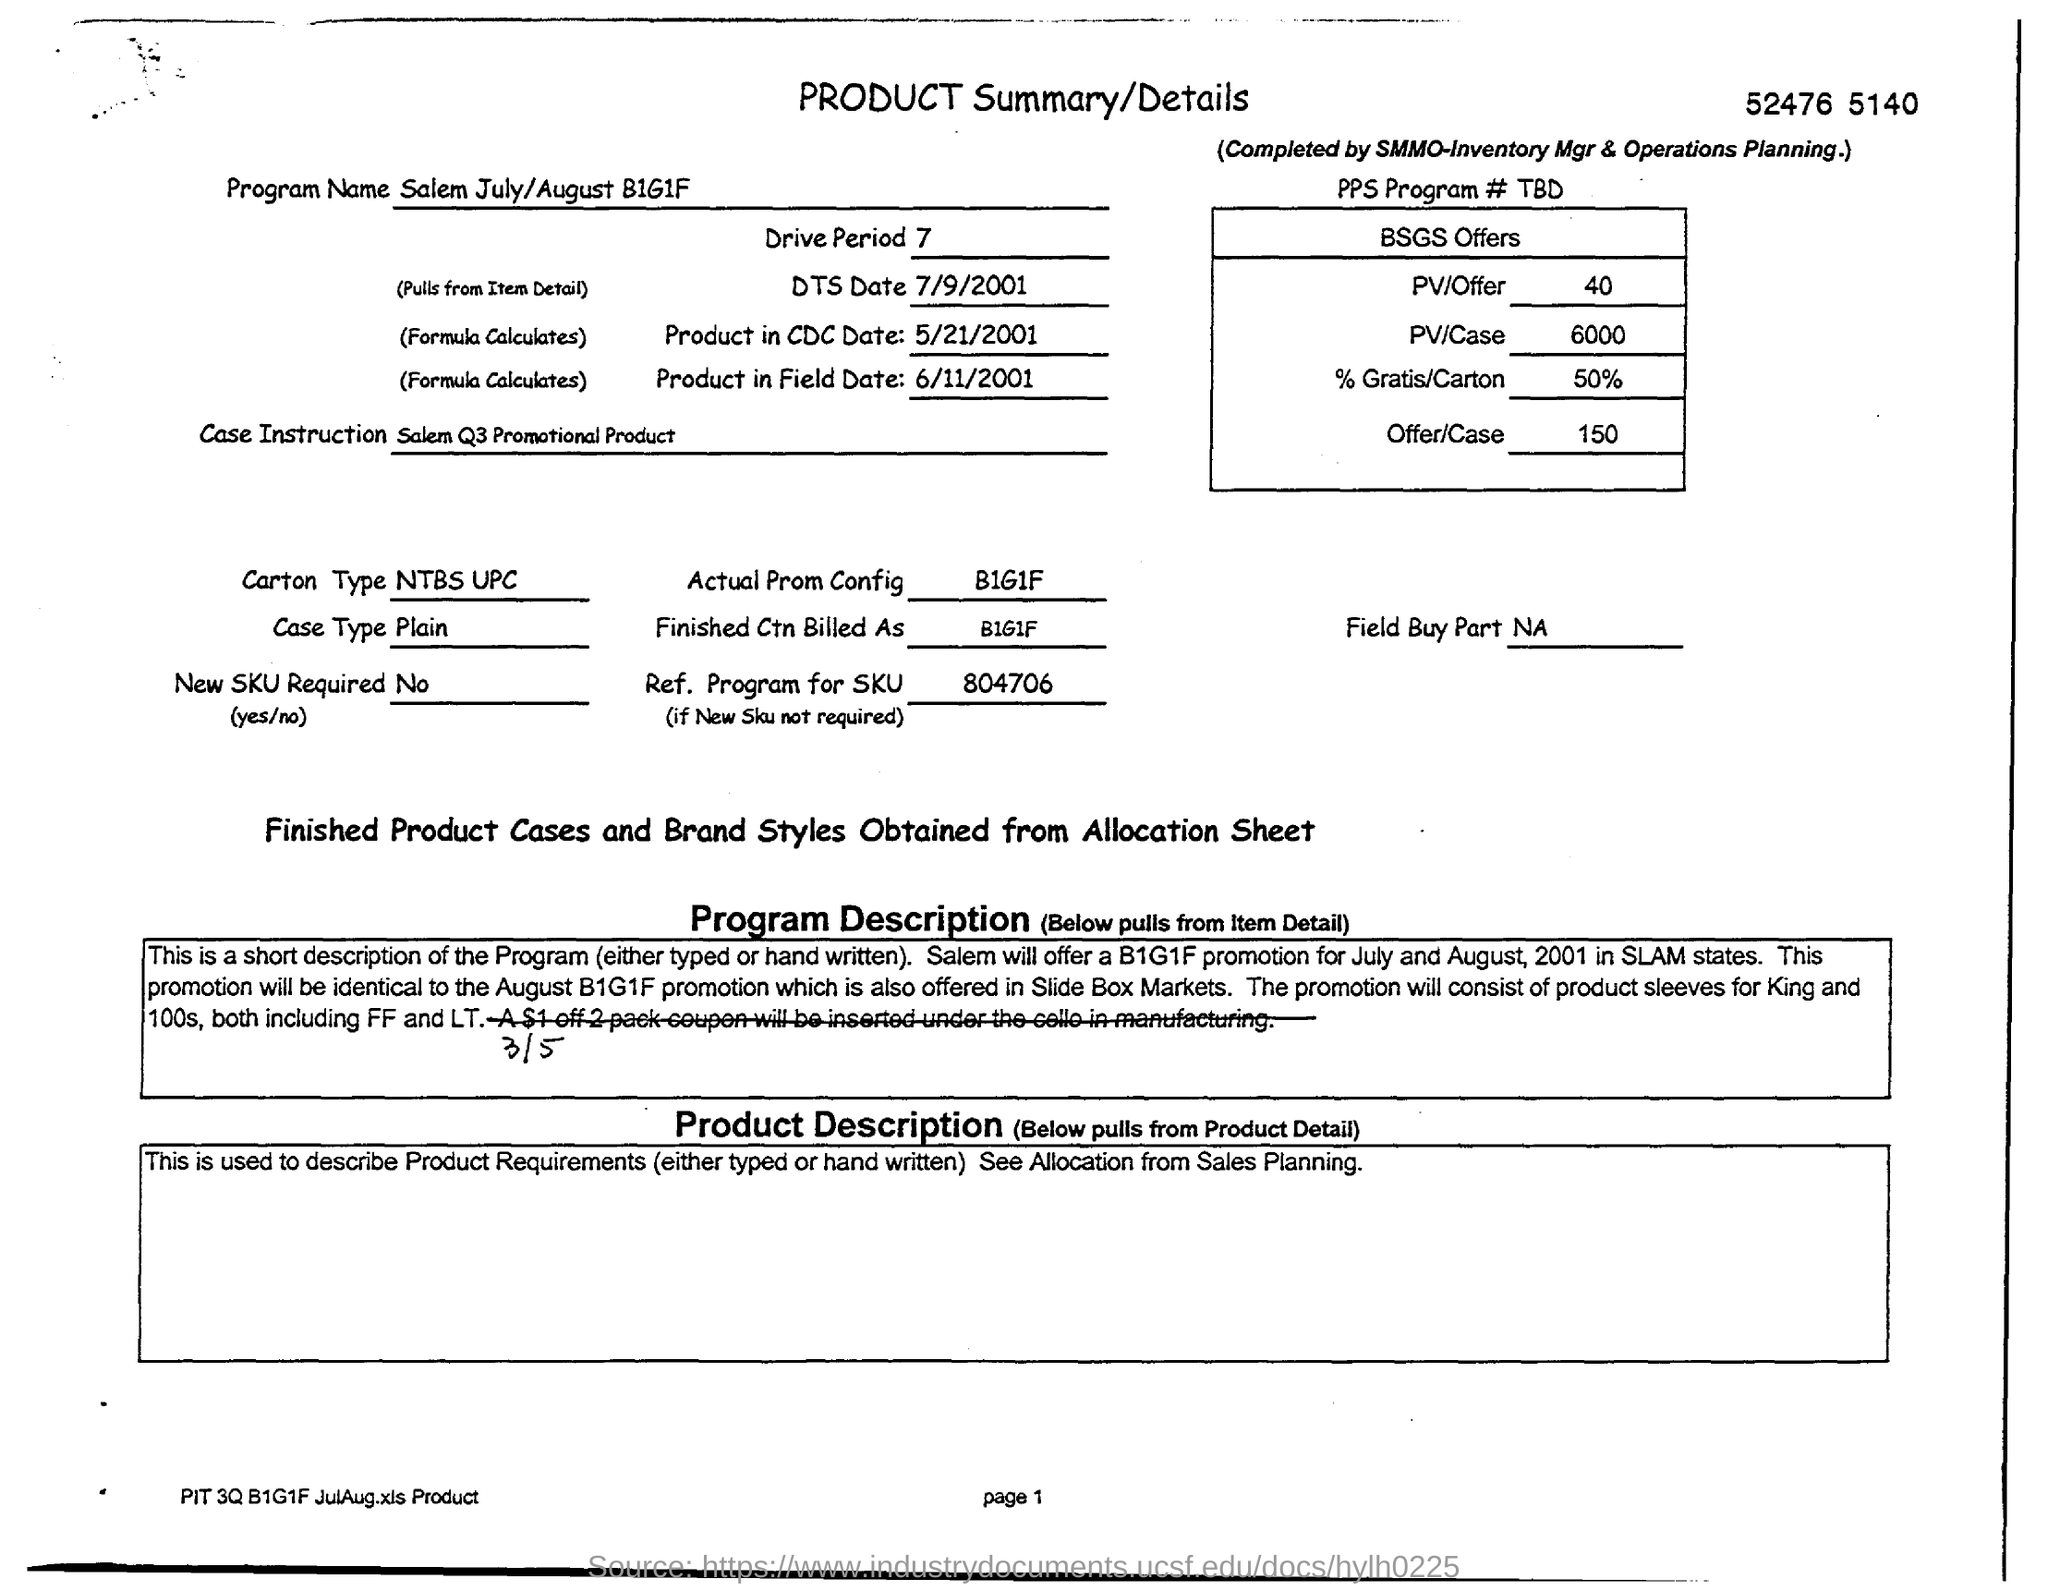Outline some significant characteristics in this image. The case type is plain. The Carton Type is NTBS with a UPC code. The drive period is a time frame during which a drive operation is performed on a storage device. 